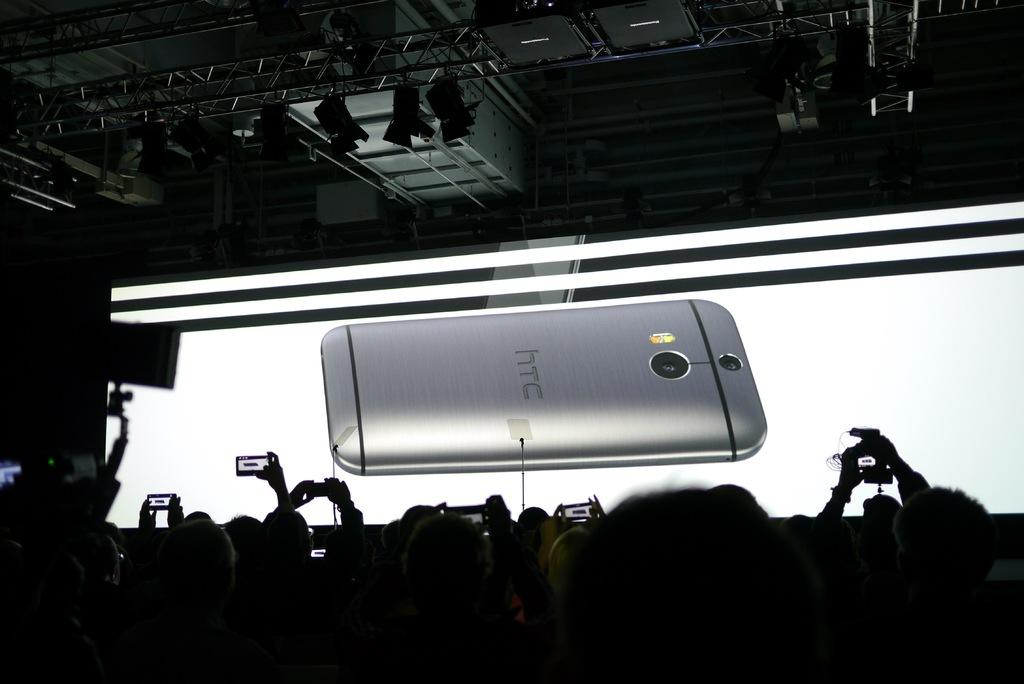<image>
Share a concise interpretation of the image provided. People looking at a screen with a phone which says HTC on it. 